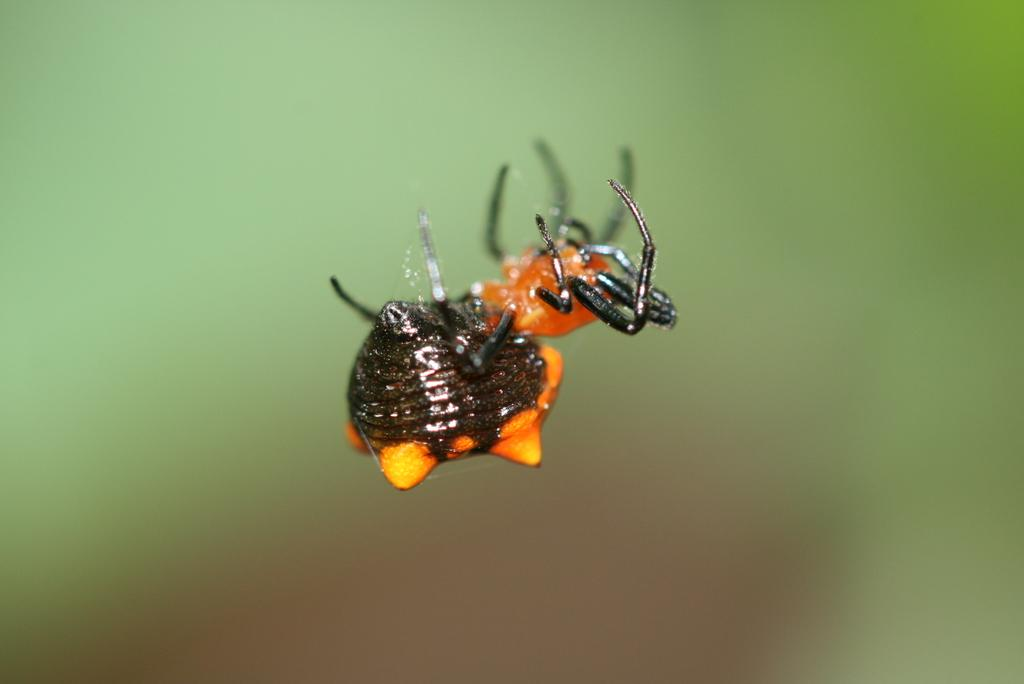What is present in the image? There is an insect in the image. Where is the insect located? The insect is on a web. Can you describe the background of the image? The background of the image is blurry. What type of butter is being used by the rat in the image? There is no butter or rat present in the image; it features an insect on a web with a blurry background. 